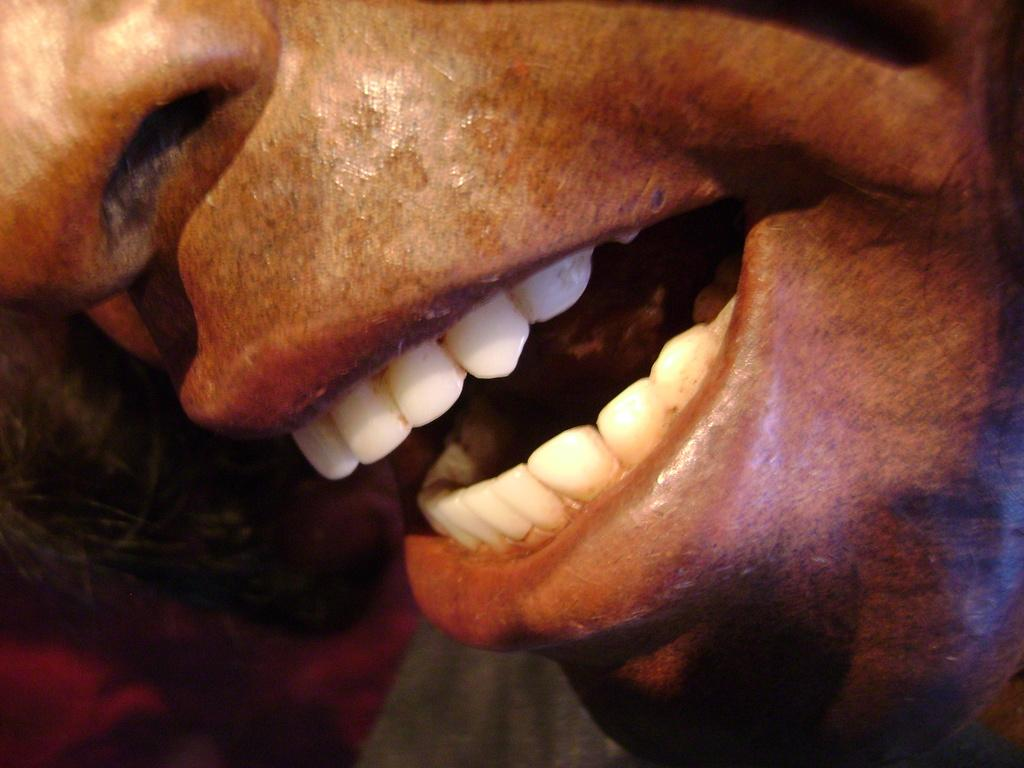What is the main focus of the image? The image provides a close view of a person. What facial features of the person can be seen in the image? The person's nose, lips, and teeth are visible in the image. What type of curtain can be seen hanging behind the person in the image? There is no curtain visible in the image; it is a close view of a person's face. 